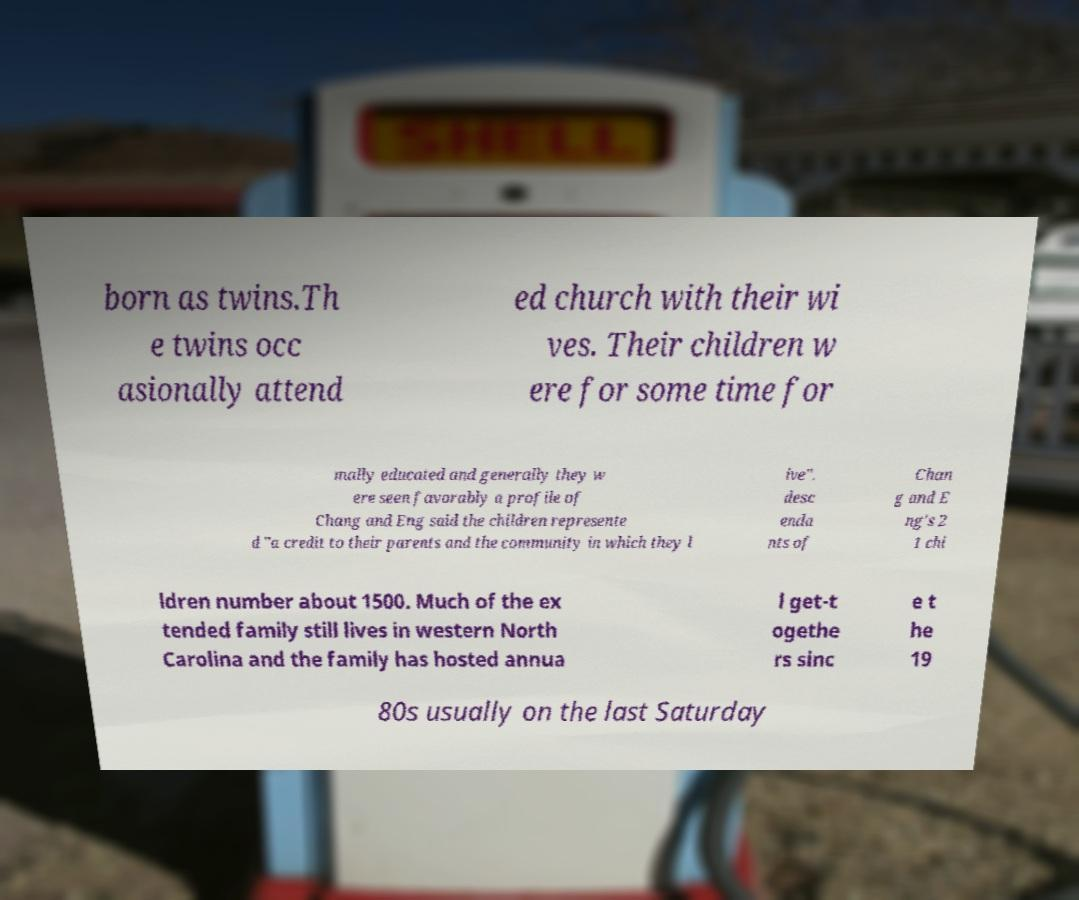Can you read and provide the text displayed in the image?This photo seems to have some interesting text. Can you extract and type it out for me? born as twins.Th e twins occ asionally attend ed church with their wi ves. Their children w ere for some time for mally educated and generally they w ere seen favorably a profile of Chang and Eng said the children represente d "a credit to their parents and the community in which they l ive". desc enda nts of Chan g and E ng's 2 1 chi ldren number about 1500. Much of the ex tended family still lives in western North Carolina and the family has hosted annua l get-t ogethe rs sinc e t he 19 80s usually on the last Saturday 